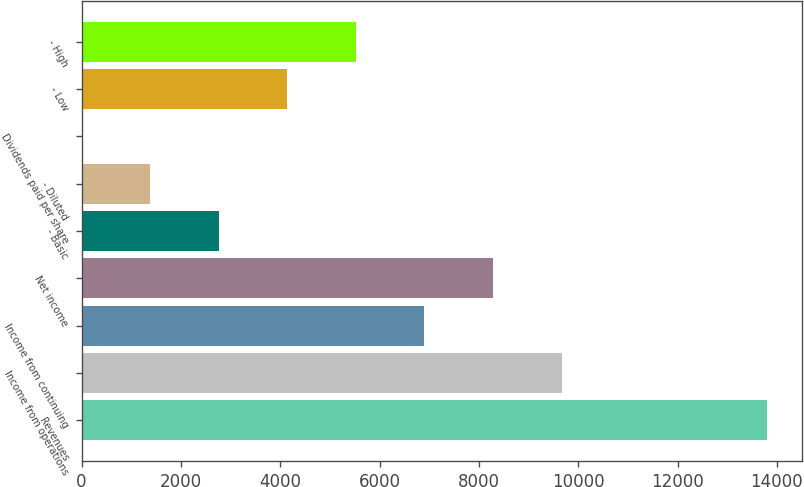Convert chart. <chart><loc_0><loc_0><loc_500><loc_500><bar_chart><fcel>Revenues<fcel>Income from operations<fcel>Income from continuing<fcel>Net income<fcel>- Basic<fcel>- Diluted<fcel>Dividends paid per share<fcel>- Low<fcel>- High<nl><fcel>13807<fcel>9664.96<fcel>6903.6<fcel>8284.28<fcel>2761.56<fcel>1380.88<fcel>0.2<fcel>4142.24<fcel>5522.92<nl></chart> 